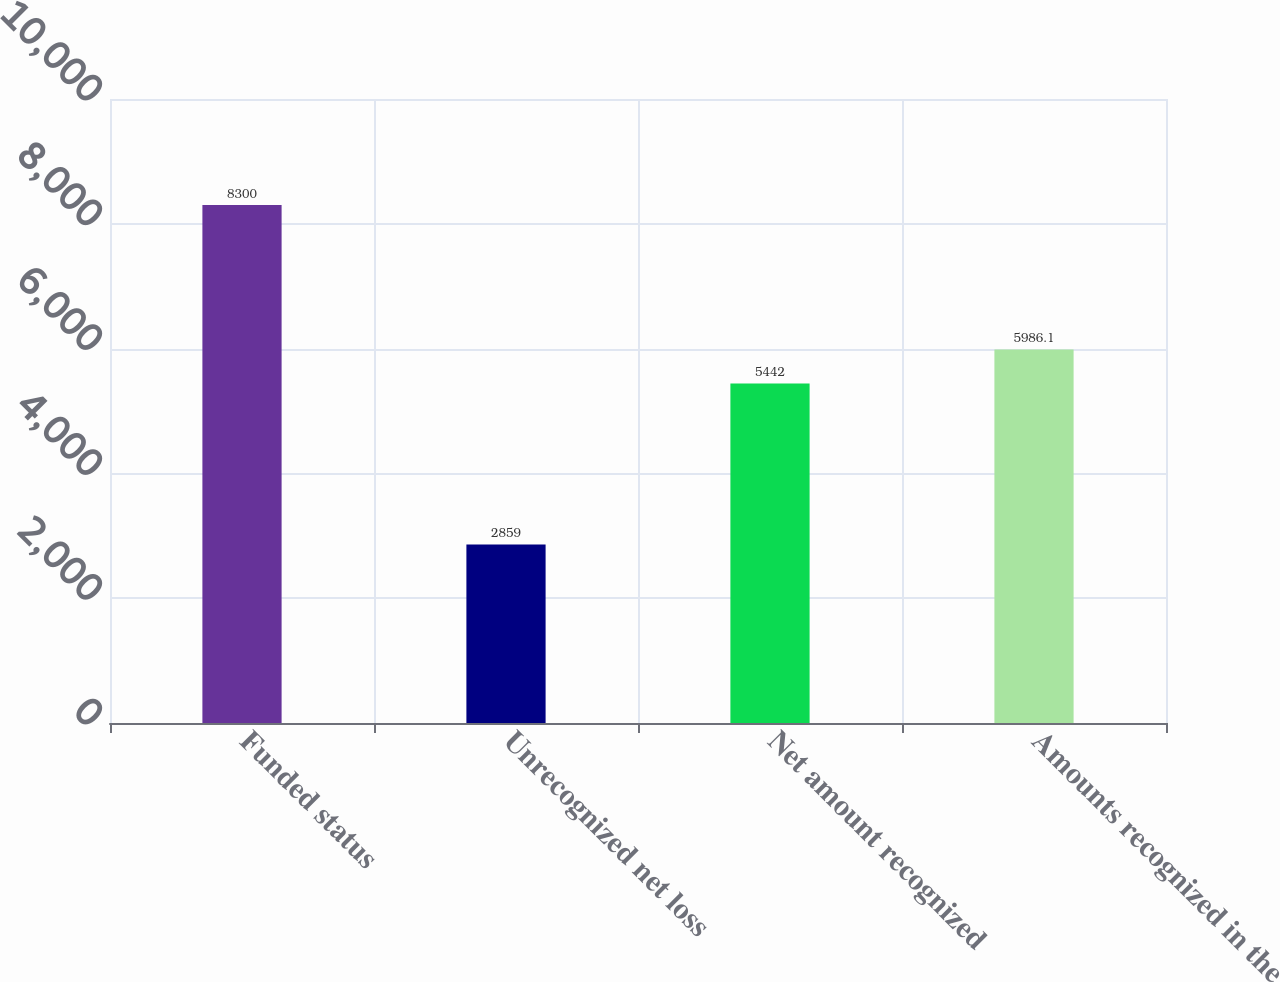Convert chart to OTSL. <chart><loc_0><loc_0><loc_500><loc_500><bar_chart><fcel>Funded status<fcel>Unrecognized net loss<fcel>Net amount recognized<fcel>Amounts recognized in the<nl><fcel>8300<fcel>2859<fcel>5442<fcel>5986.1<nl></chart> 